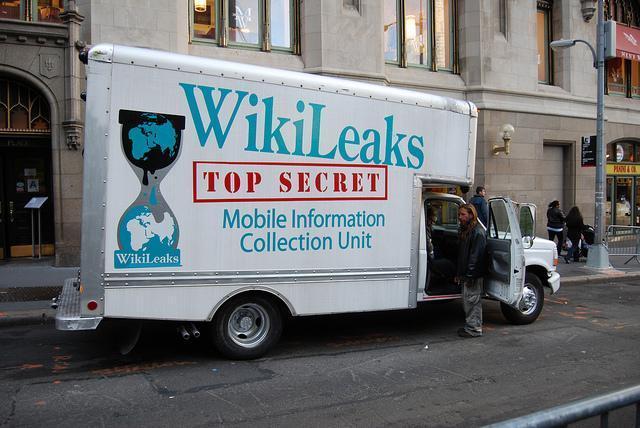How many white cars are on the road?
Give a very brief answer. 0. 